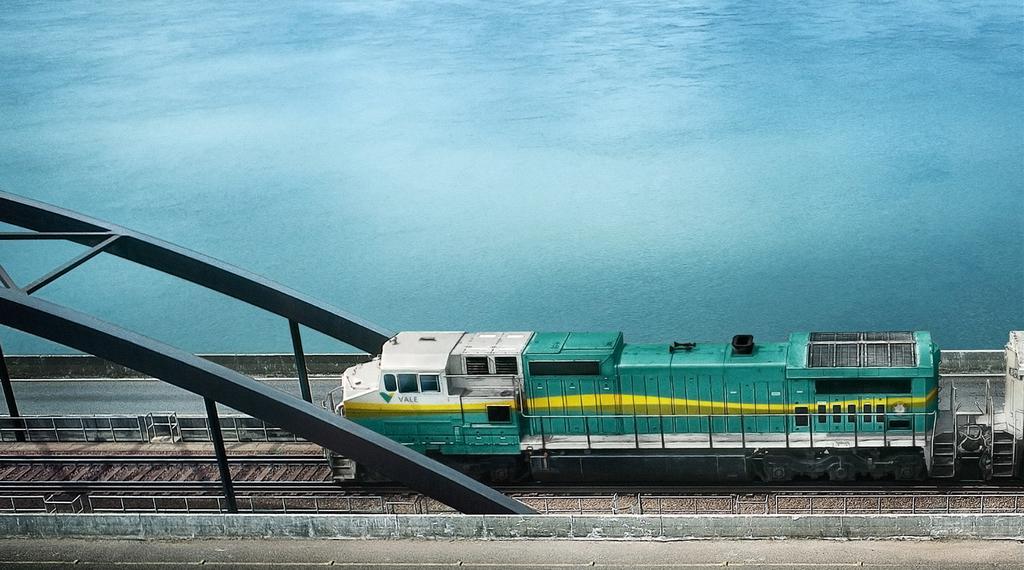Please provide a concise description of this image. In this image I can see a train on a railway track. Here I can see poles, fence and water. 